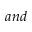Convert formula to latex. <formula><loc_0><loc_0><loc_500><loc_500>a n d</formula> 